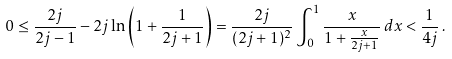Convert formula to latex. <formula><loc_0><loc_0><loc_500><loc_500>0 \leq \frac { 2 j } { 2 j - 1 } - 2 j \ln \left ( 1 + \frac { 1 } { 2 j + 1 } \right ) = \frac { 2 j } { ( 2 j + 1 ) ^ { 2 } } \int _ { 0 } ^ { 1 } \frac { x } { 1 + \frac { x } { 2 j + 1 } } \, d x < \frac { 1 } { 4 j } \, .</formula> 